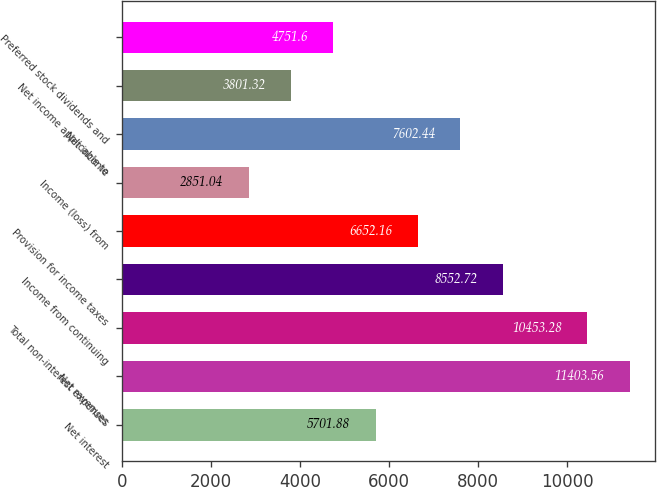Convert chart. <chart><loc_0><loc_0><loc_500><loc_500><bar_chart><fcel>Net interest<fcel>Net revenues<fcel>Total non-interest expenses<fcel>Income from continuing<fcel>Provision for income taxes<fcel>Income (loss) from<fcel>Net income<fcel>Net income applicable to<fcel>Preferred stock dividends and<nl><fcel>5701.88<fcel>11403.6<fcel>10453.3<fcel>8552.72<fcel>6652.16<fcel>2851.04<fcel>7602.44<fcel>3801.32<fcel>4751.6<nl></chart> 